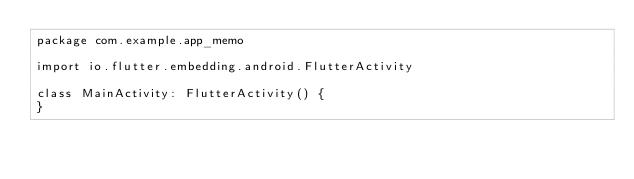Convert code to text. <code><loc_0><loc_0><loc_500><loc_500><_Kotlin_>package com.example.app_memo

import io.flutter.embedding.android.FlutterActivity

class MainActivity: FlutterActivity() {
}
</code> 